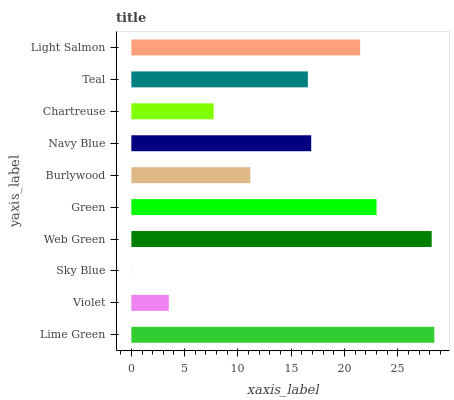Is Sky Blue the minimum?
Answer yes or no. Yes. Is Lime Green the maximum?
Answer yes or no. Yes. Is Violet the minimum?
Answer yes or no. No. Is Violet the maximum?
Answer yes or no. No. Is Lime Green greater than Violet?
Answer yes or no. Yes. Is Violet less than Lime Green?
Answer yes or no. Yes. Is Violet greater than Lime Green?
Answer yes or no. No. Is Lime Green less than Violet?
Answer yes or no. No. Is Navy Blue the high median?
Answer yes or no. Yes. Is Teal the low median?
Answer yes or no. Yes. Is Web Green the high median?
Answer yes or no. No. Is Chartreuse the low median?
Answer yes or no. No. 